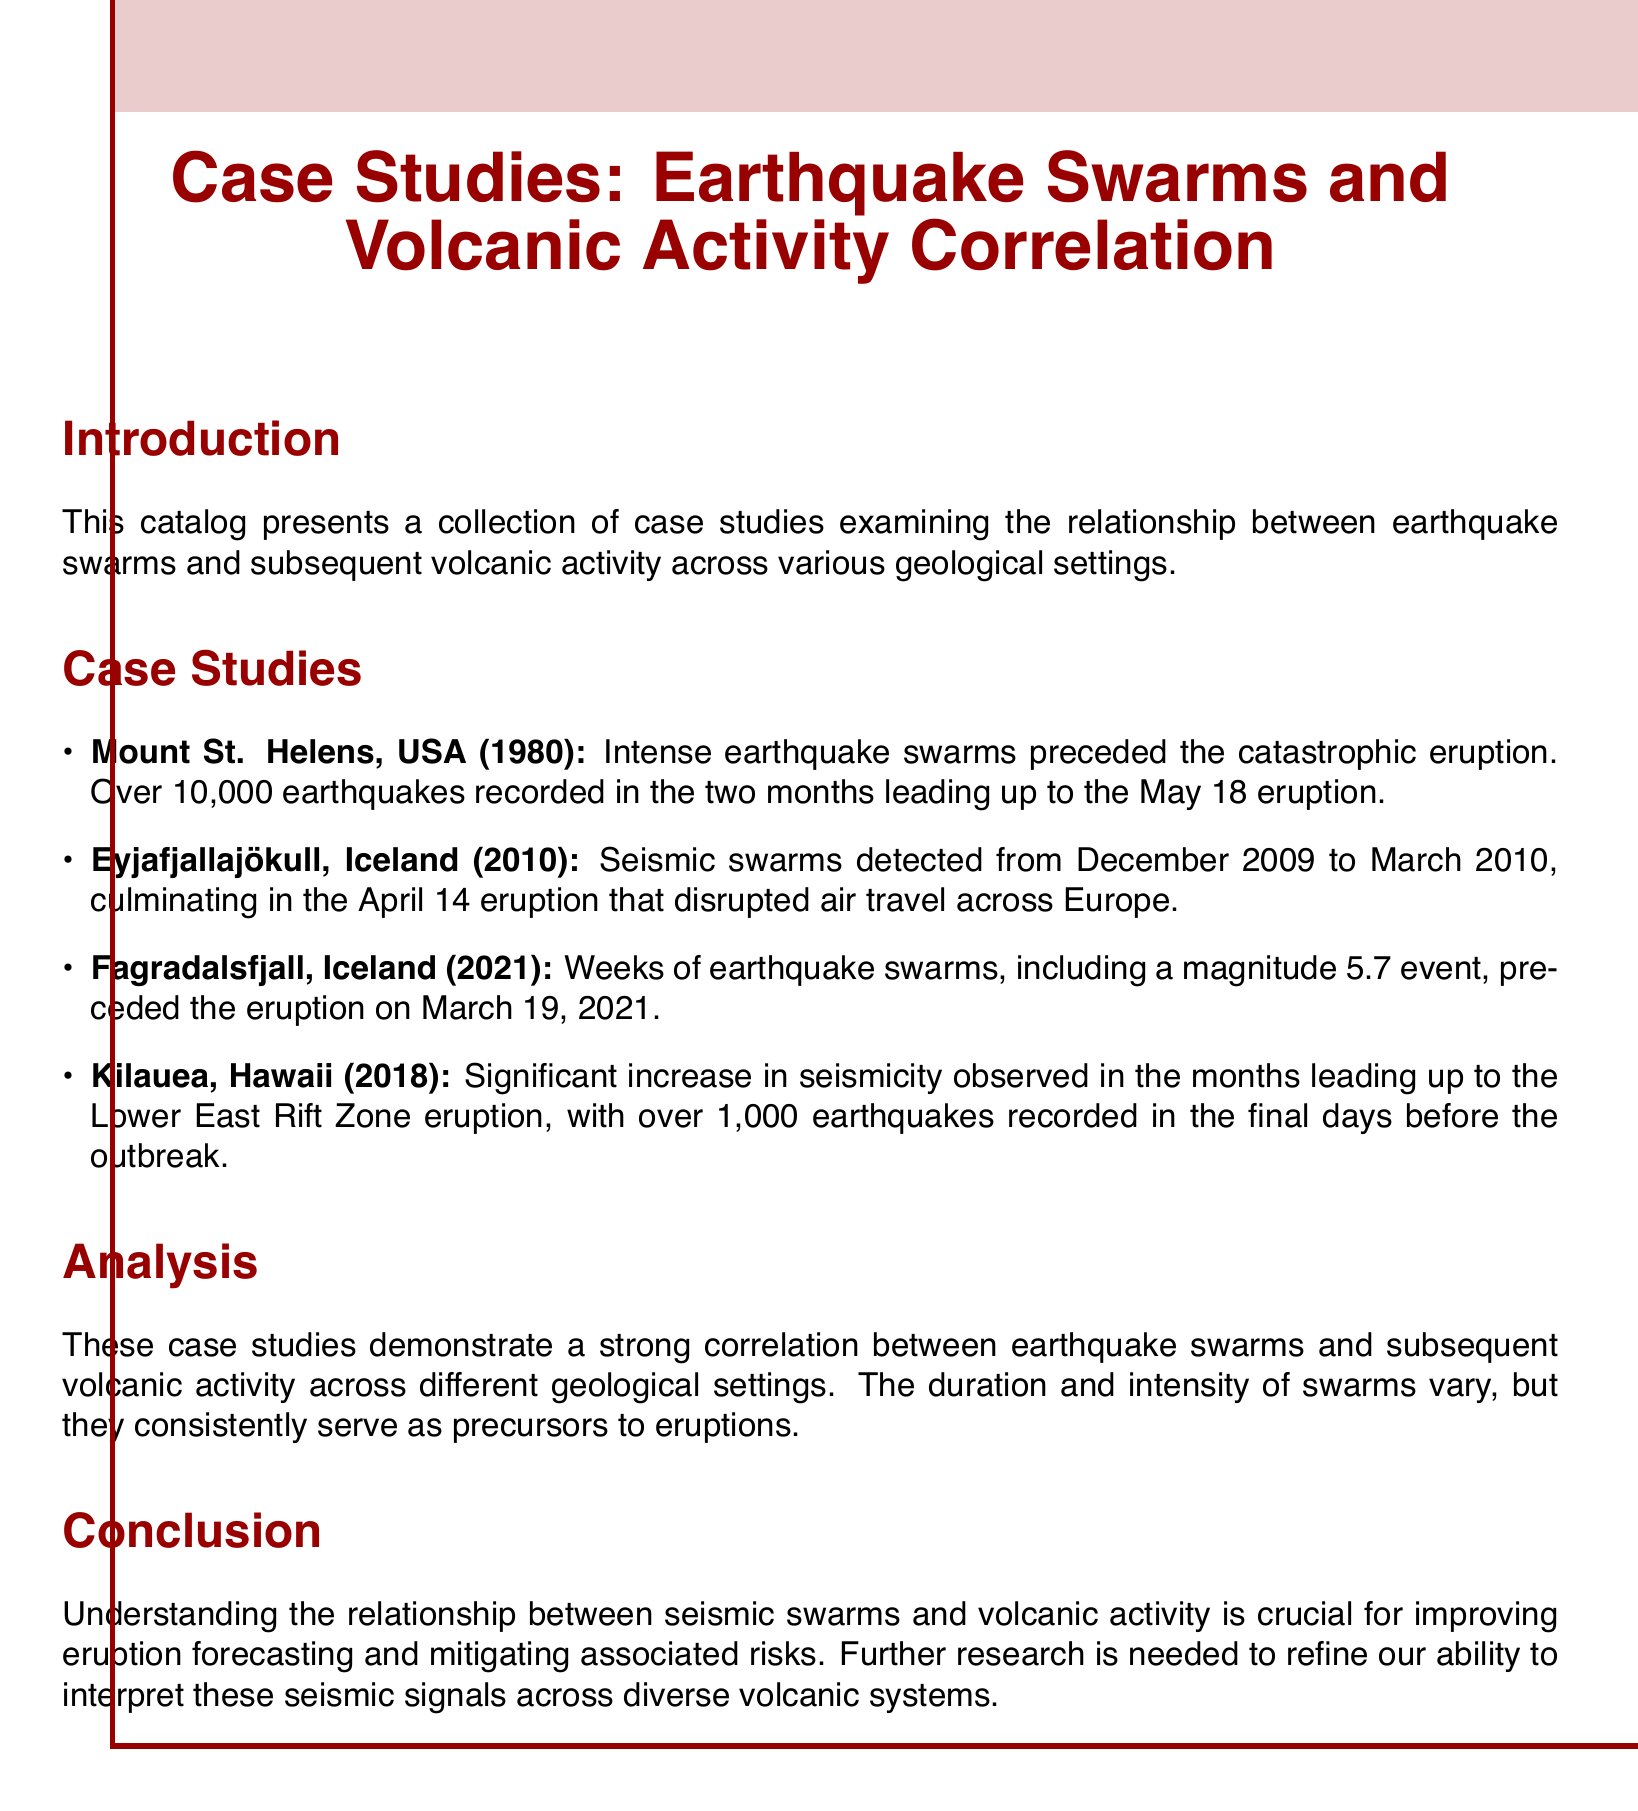What is the title of the document? The title of the document is presented prominently at the beginning, which is a summary of the content it covers.
Answer: Case Studies: Earthquake Swarms and Volcanic Activity Correlation How many earthquakes were recorded before the Mount St. Helens eruption? The document specifies that during the two months leading up to the eruption, a significant number of earthquakes were recorded.
Answer: Over 10,000 earthquakes When did the Eyjafjallajökull eruption occur? The document specifies the date that marks the occurrence of the eruption following the seismic swarms.
Answer: April 14, 2010 What significant event preceded the eruption of Fagradalsfjall? The document indicates notable seismic activity that took place before the eruption, highlighting its significance.
Answer: A magnitude 5.7 event What year did the Kilauea Lower East Rift Zone eruption take place? The document directly points out the year of the eruption linked to the increased seismic activity.
Answer: 2018 What is emphasized as crucial for improving eruption forecasting? The document highlights a key relationship that is important for better understanding and predicting volcanic eruptions.
Answer: Understanding the relationship between seismic swarms and volcanic activity 